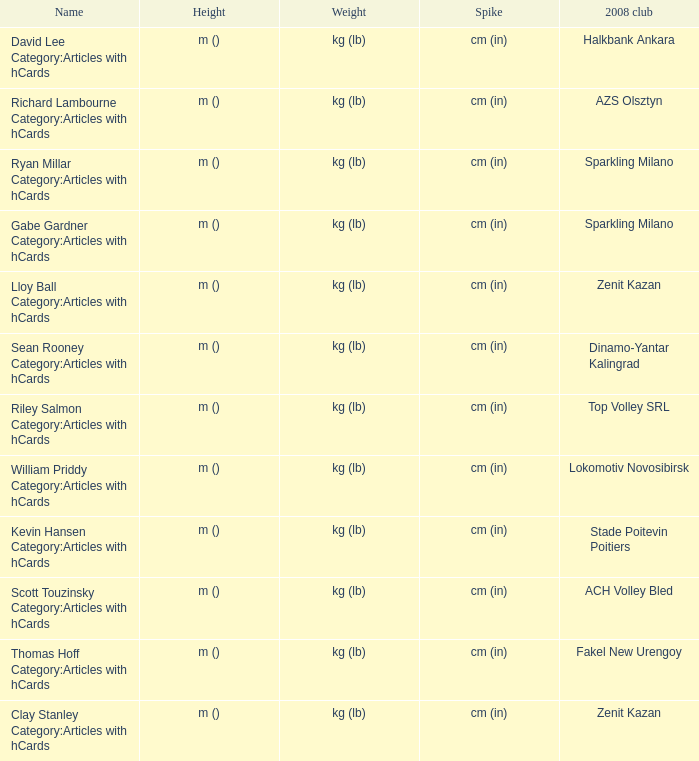What is the spike for the 2008 club of Lokomotiv Novosibirsk? Cm (in). 